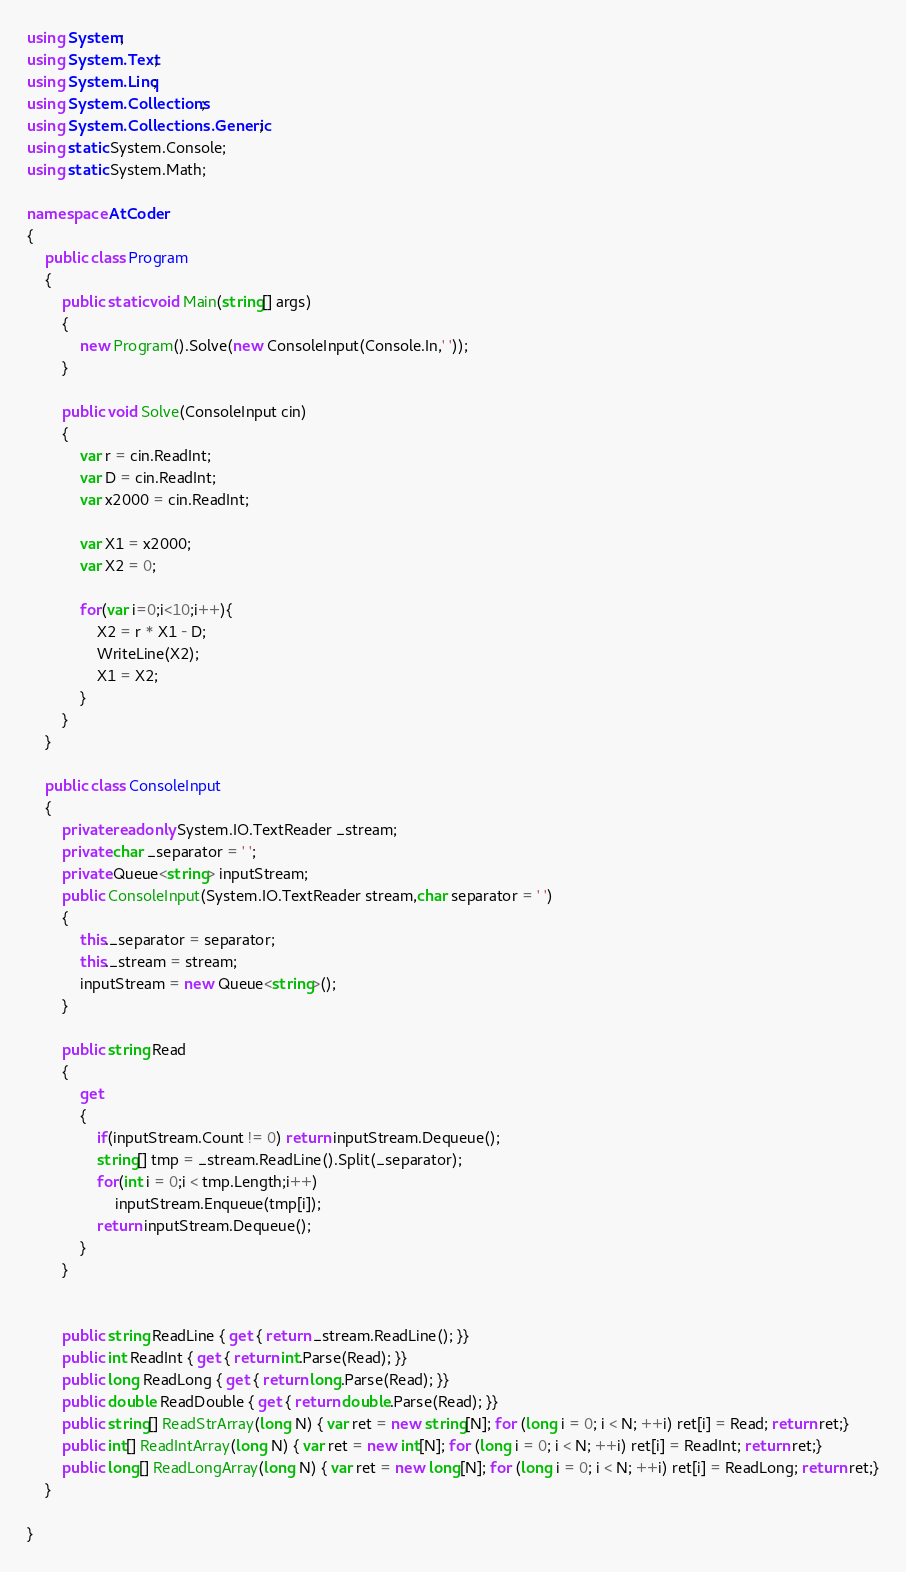Convert code to text. <code><loc_0><loc_0><loc_500><loc_500><_C#_>using System;
using System.Text;
using System.Linq;
using System.Collections;
using System.Collections.Generic;
using static System.Console;
using static System.Math;

namespace AtCoder
{
    public class Program
    {
        public static void Main(string[] args)
        {
            new Program().Solve(new ConsoleInput(Console.In,' '));
        }

        public void Solve(ConsoleInput cin)
        {
            var r = cin.ReadInt;
            var D = cin.ReadInt;
            var x2000 = cin.ReadInt;

            var X1 = x2000;
            var X2 = 0;

            for(var i=0;i<10;i++){
                X2 = r * X1 - D;
                WriteLine(X2);
                X1 = X2;
            }
        }
    }

    public class ConsoleInput
    {
        private readonly System.IO.TextReader _stream;
        private char _separator = ' ';
        private Queue<string> inputStream;
        public ConsoleInput(System.IO.TextReader stream,char separator = ' ')
        {
            this._separator = separator;
            this._stream = stream;
            inputStream = new Queue<string>();
        }

        public string Read
        {
            get
            {
                if(inputStream.Count != 0) return inputStream.Dequeue();
                string[] tmp = _stream.ReadLine().Split(_separator);
                for(int i = 0;i < tmp.Length;i++)
                    inputStream.Enqueue(tmp[i]);
                return inputStream.Dequeue();
            }
        }

        
        public string ReadLine { get { return _stream.ReadLine(); }}
        public int ReadInt { get { return int.Parse(Read); }}
        public long ReadLong { get { return long.Parse(Read); }}
        public double ReadDouble { get { return double.Parse(Read); }}
        public string[] ReadStrArray(long N) { var ret = new string[N]; for (long i = 0; i < N; ++i) ret[i] = Read; return ret;}
        public int[] ReadIntArray(long N) { var ret = new int[N]; for (long i = 0; i < N; ++i) ret[i] = ReadInt; return ret;}
        public long[] ReadLongArray(long N) { var ret = new long[N]; for (long i = 0; i < N; ++i) ret[i] = ReadLong; return ret;}
    }

}
</code> 